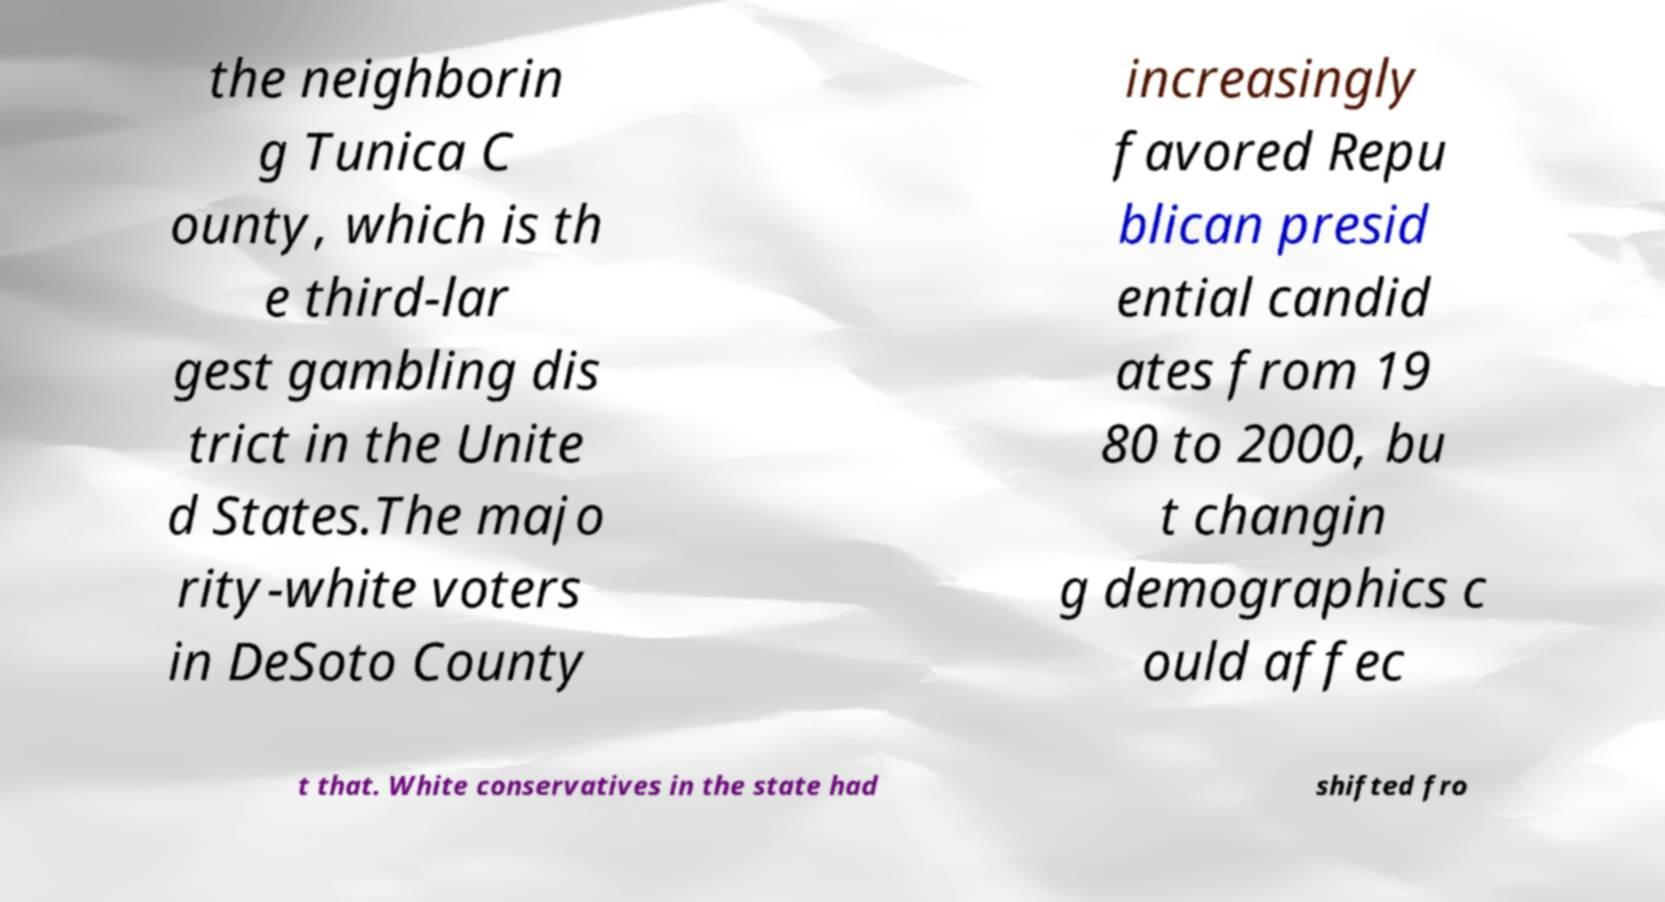There's text embedded in this image that I need extracted. Can you transcribe it verbatim? the neighborin g Tunica C ounty, which is th e third-lar gest gambling dis trict in the Unite d States.The majo rity-white voters in DeSoto County increasingly favored Repu blican presid ential candid ates from 19 80 to 2000, bu t changin g demographics c ould affec t that. White conservatives in the state had shifted fro 